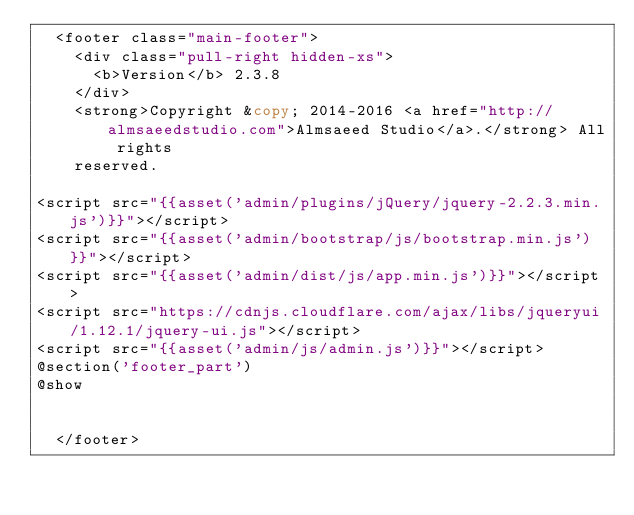Convert code to text. <code><loc_0><loc_0><loc_500><loc_500><_PHP_>  <footer class="main-footer">
    <div class="pull-right hidden-xs">
      <b>Version</b> 2.3.8
    </div>
    <strong>Copyright &copy; 2014-2016 <a href="http://almsaeedstudio.com">Almsaeed Studio</a>.</strong> All rights
    reserved.

<script src="{{asset('admin/plugins/jQuery/jquery-2.2.3.min.js')}}"></script>
<script src="{{asset('admin/bootstrap/js/bootstrap.min.js')}}"></script>
<script src="{{asset('admin/dist/js/app.min.js')}}"></script>
<script src="https://cdnjs.cloudflare.com/ajax/libs/jqueryui/1.12.1/jquery-ui.js"></script>
<script src="{{asset('admin/js/admin.js')}}"></script>
@section('footer_part')
@show


  </footer></code> 